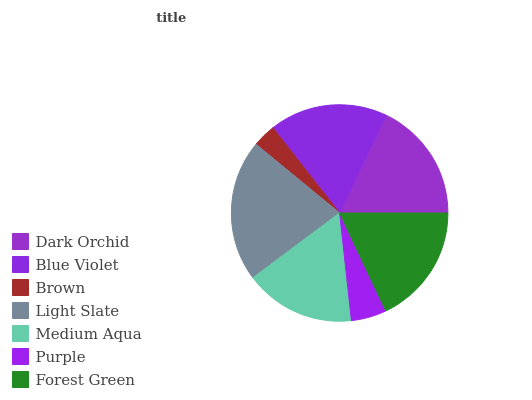Is Brown the minimum?
Answer yes or no. Yes. Is Light Slate the maximum?
Answer yes or no. Yes. Is Blue Violet the minimum?
Answer yes or no. No. Is Blue Violet the maximum?
Answer yes or no. No. Is Dark Orchid greater than Blue Violet?
Answer yes or no. Yes. Is Blue Violet less than Dark Orchid?
Answer yes or no. Yes. Is Blue Violet greater than Dark Orchid?
Answer yes or no. No. Is Dark Orchid less than Blue Violet?
Answer yes or no. No. Is Blue Violet the high median?
Answer yes or no. Yes. Is Blue Violet the low median?
Answer yes or no. Yes. Is Purple the high median?
Answer yes or no. No. Is Dark Orchid the low median?
Answer yes or no. No. 